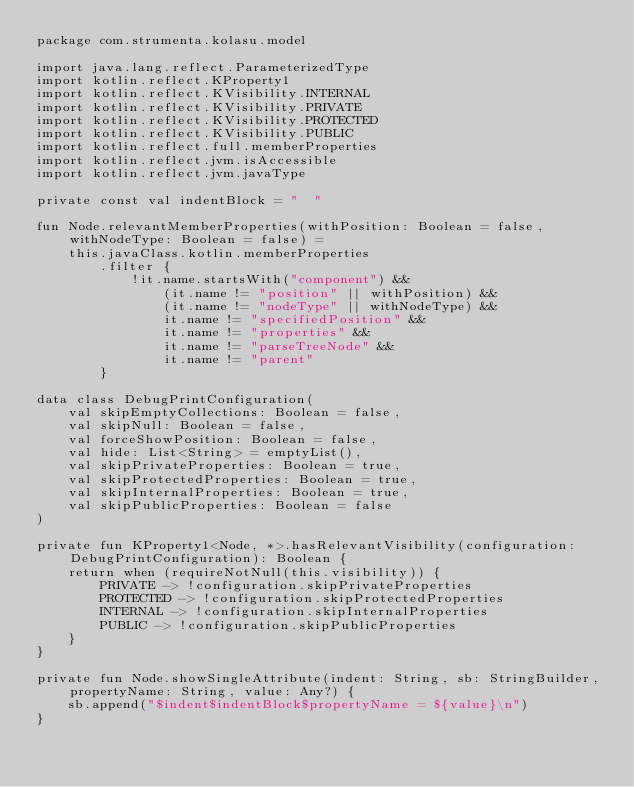<code> <loc_0><loc_0><loc_500><loc_500><_Kotlin_>package com.strumenta.kolasu.model

import java.lang.reflect.ParameterizedType
import kotlin.reflect.KProperty1
import kotlin.reflect.KVisibility.INTERNAL
import kotlin.reflect.KVisibility.PRIVATE
import kotlin.reflect.KVisibility.PROTECTED
import kotlin.reflect.KVisibility.PUBLIC
import kotlin.reflect.full.memberProperties
import kotlin.reflect.jvm.isAccessible
import kotlin.reflect.jvm.javaType

private const val indentBlock = "  "

fun Node.relevantMemberProperties(withPosition: Boolean = false, withNodeType: Boolean = false) =
    this.javaClass.kotlin.memberProperties
        .filter {
            !it.name.startsWith("component") &&
                (it.name != "position" || withPosition) &&
                (it.name != "nodeType" || withNodeType) &&
                it.name != "specifiedPosition" &&
                it.name != "properties" &&
                it.name != "parseTreeNode" &&
                it.name != "parent"
        }

data class DebugPrintConfiguration(
    val skipEmptyCollections: Boolean = false,
    val skipNull: Boolean = false,
    val forceShowPosition: Boolean = false,
    val hide: List<String> = emptyList(),
    val skipPrivateProperties: Boolean = true,
    val skipProtectedProperties: Boolean = true,
    val skipInternalProperties: Boolean = true,
    val skipPublicProperties: Boolean = false
)

private fun KProperty1<Node, *>.hasRelevantVisibility(configuration: DebugPrintConfiguration): Boolean {
    return when (requireNotNull(this.visibility)) {
        PRIVATE -> !configuration.skipPrivateProperties
        PROTECTED -> !configuration.skipProtectedProperties
        INTERNAL -> !configuration.skipInternalProperties
        PUBLIC -> !configuration.skipPublicProperties
    }
}

private fun Node.showSingleAttribute(indent: String, sb: StringBuilder, propertyName: String, value: Any?) {
    sb.append("$indent$indentBlock$propertyName = ${value}\n")
}
</code> 